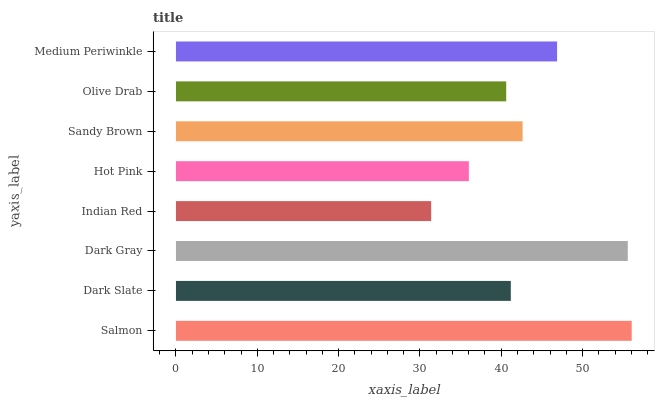Is Indian Red the minimum?
Answer yes or no. Yes. Is Salmon the maximum?
Answer yes or no. Yes. Is Dark Slate the minimum?
Answer yes or no. No. Is Dark Slate the maximum?
Answer yes or no. No. Is Salmon greater than Dark Slate?
Answer yes or no. Yes. Is Dark Slate less than Salmon?
Answer yes or no. Yes. Is Dark Slate greater than Salmon?
Answer yes or no. No. Is Salmon less than Dark Slate?
Answer yes or no. No. Is Sandy Brown the high median?
Answer yes or no. Yes. Is Dark Slate the low median?
Answer yes or no. Yes. Is Medium Periwinkle the high median?
Answer yes or no. No. Is Dark Gray the low median?
Answer yes or no. No. 